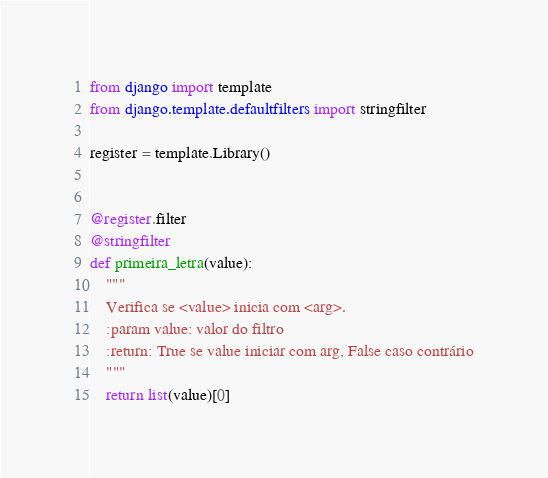<code> <loc_0><loc_0><loc_500><loc_500><_Python_>from django import template
from django.template.defaultfilters import stringfilter

register = template.Library()


@register.filter
@stringfilter
def primeira_letra(value):
    """
    Verifica se <value> inicia com <arg>.
    :param value: valor do filtro
    :return: True se value iniciar com arg, False caso contrário
    """
    return list(value)[0]
</code> 